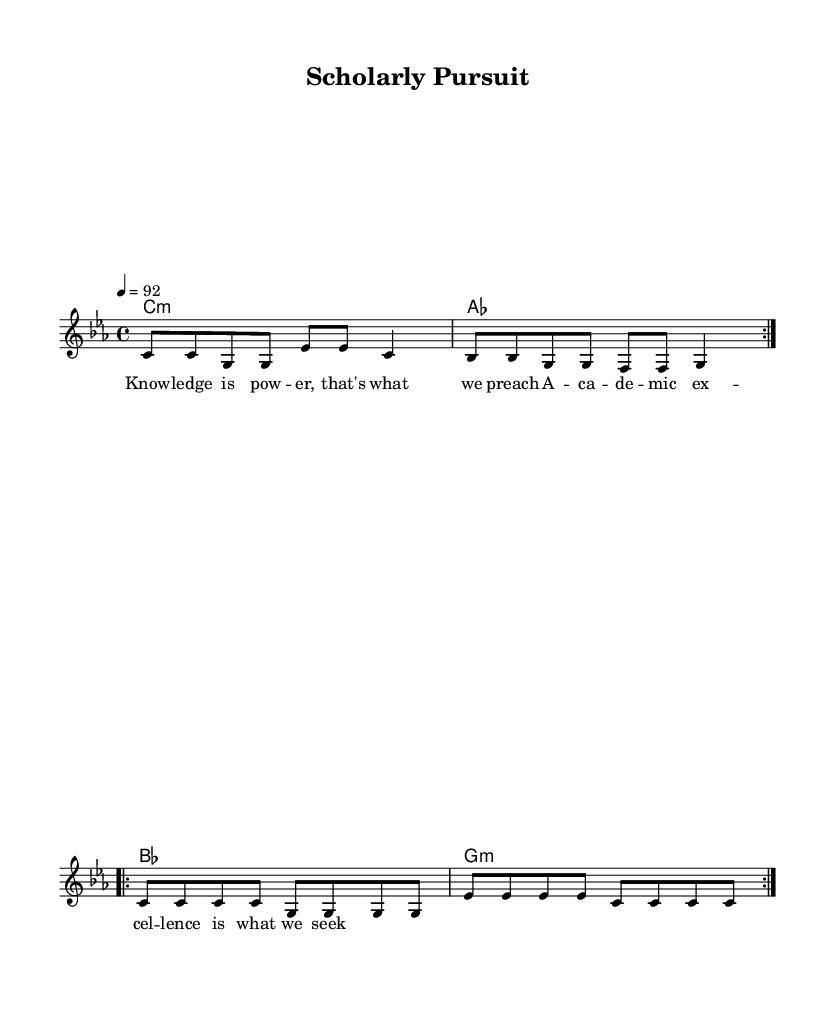What is the key signature of this music? The key signature is C minor, which is indicated by three flats (B♭, E♭, A♭).
Answer: C minor What is the time signature of this music? The time signature is indicated by "4/4," which means there are four beats in each measure and a quarter note gets one beat.
Answer: 4/4 What is the tempo marking of this music? The tempo marking is given as "4 = 92," indicating that there should be 92 beats per minute at quarter note equal.
Answer: 92 How many measures are in the melody section? The melody section consists of four measures based on the notes above, clearly separated by bar lines in the music.
Answer: Four What is the main focus of the lyrics in this rap piece? The lyrics emphasize the importance of knowledge and academic excellence, reinforcing the theme of scholarly pursuit.
Answer: Knowledge is power What type of chord is used on the first measure? The first measure features a C minor chord, which is indicated by "c1:m" as written in the harmonies section.
Answer: C minor What lyrical theme does this rap song promote? The lyrical theme promotes the pursuit of academic excellence and the empowerment that comes through knowledge.
Answer: Academic excellence 